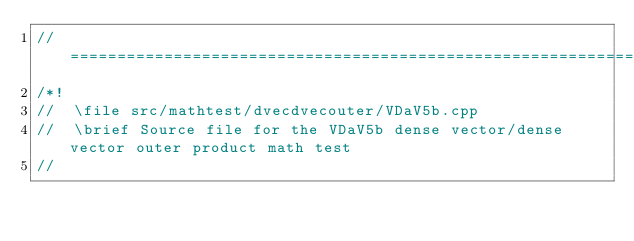<code> <loc_0><loc_0><loc_500><loc_500><_C++_>//=================================================================================================
/*!
//  \file src/mathtest/dvecdvecouter/VDaV5b.cpp
//  \brief Source file for the VDaV5b dense vector/dense vector outer product math test
//</code> 